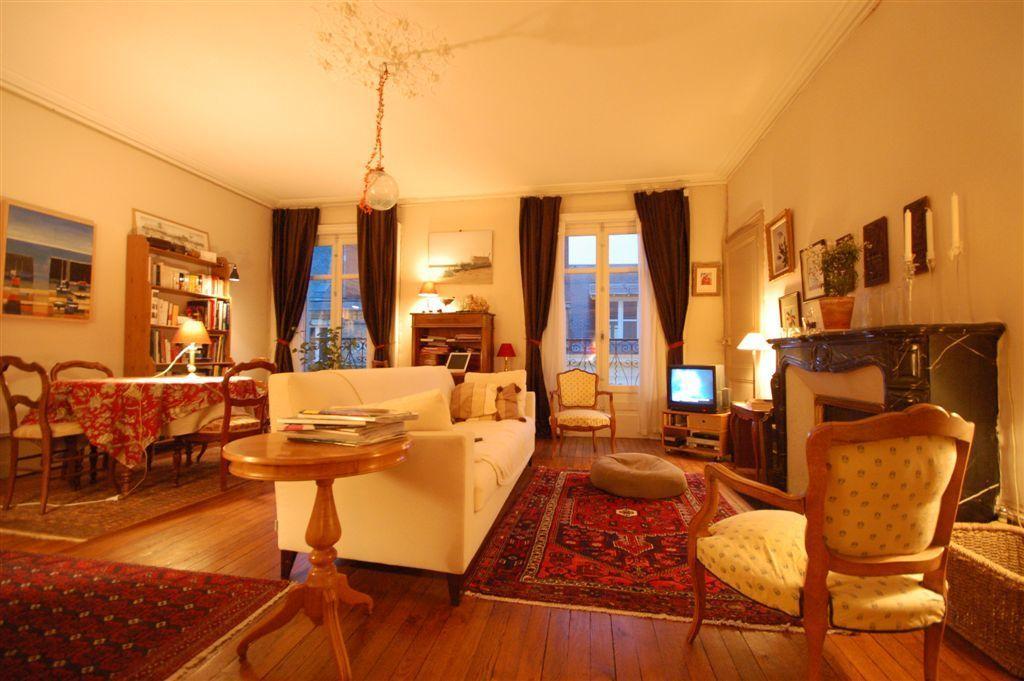Can you describe this image briefly? This image is taken inside the living room of a house. In this image there are many furniture like sofa, chair, dining table , teapoy, fire place. And to the top there is a roof to which a light is hanged. To the left there is a photo frame on the wall. 